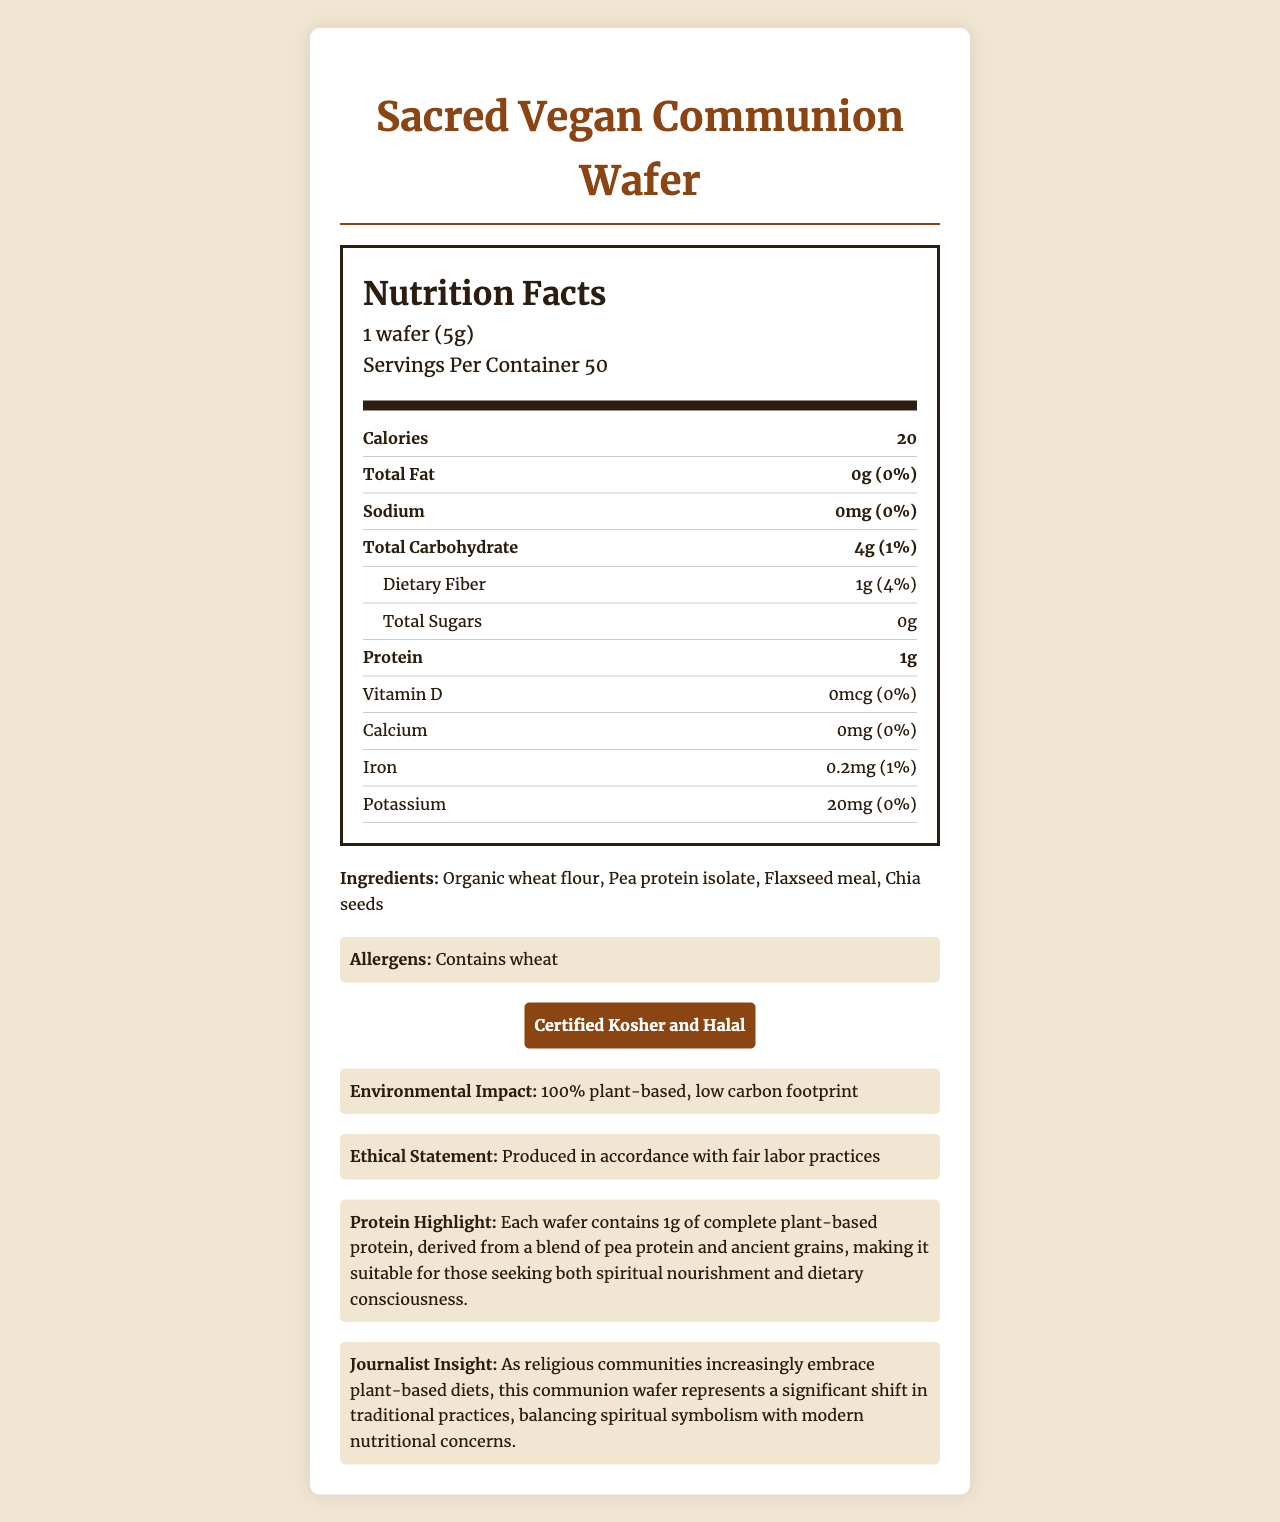what is the product name? The product name is explicitly mentioned at the top of the document.
Answer: Sacred Vegan Communion Wafer how many servings per container are there? The servings per container is listed under the serving information section.
Answer: 50 what is the serving size? The serving size is given in the serving information section.
Answer: 1 wafer (5g) how many calories does one serving contain? The number of calories per serving is listed in the nutrition facts section.
Answer: 20 what is the total carbohydrate content per serving? The total carbohydrate content per serving is listed in the nutrition facts section.
Answer: 4g what type of certification does the product have? A. Certified Organic B. Certified Humane C. Certified Kosher and Halal D. Certified Gluten-Free The certification listed in the document is "Certified Kosher and Halal".
Answer: C how much protein does one wafer contain? The protein content per serving is listed in the nutrition facts section.
Answer: 1g does the product contain any allergens? The document states, "Contains wheat" under the allergens section.
Answer: Yes what ingredients are used in the product? The ingredients are listed in the ingredients section.
Answer: Organic wheat flour, Pea protein isolate, Flaxseed meal, Chia seeds what impact does the product have on the environment? This information is provided in the document under the environmental impact section.
Answer: 100% plant-based, low carbon footprint what is the daily value percentage of dietary fiber? The daily value percentage of dietary fiber is listed in the nutrition facts section.
Answer: 4% which ingredient provides the plant-based protein content in the wafer? A. Organic wheat flour B. Chia seeds C. Pea protein isolate D. Flaxseed meal The highlighted protein information states that the protein content is derived from pea protein isolate.
Answer: C does the product contain any added sugars? Yes/No The document states that the total sugars amount to 0g, indicating no added sugars.
Answer: No briefly summarize the main idea of this document. The document is centered around providing comprehensive details on the nutritional facts, ingredients, certifications, and ethical stance of the product.
Answer: The document provides detailed nutritional information about a product called the Sacred Vegan Communion Wafer. It highlights the product's plant-based ingredients, such as pea protein isolate, and emphasizes its certification as Kosher and Halal. The document also discusses its ecological and ethical production practices. which mineral is present in a small amount (0.2mg) in the wafer? The nutrition facts section lists the iron content as 0.2mg.
Answer: Iron what is the product's ethical statement about its production? This information is provided in the ethical statement section of the document.
Answer: Produced in accordance with fair labor practices what is the daily value percentage of sodium in one serving? The daily value percentage for sodium is listed as 0%, indicating no significant amount.
Answer: 0% how many ingredients are used in the product? The ingredients section lists four items: Organic wheat flour, Pea protein isolate, Flaxseed meal, and Chia seeds.
Answer: 4 is the document user-friendly and well-structured? Why or why not? The document is user-friendly because it is well-structured with clear headings, bold sub-sections, and highlighted areas for easy readability. The use of visual distinctions like colors and fonts enhances comprehension.
Answer: Yes what is the daily value percentage of calcium? The daily value percentage for calcium is listed as 0%, indicating no significant amount of calcium.
Answer: 0% are the production practices of the product stated in the document? If so, what do they say? The document states, "Produced in accordance with fair labor practices" in the ethical statement section.
Answer: Yes does the product contain Vitamin D? The document indicates that the amount of Vitamin D is 0mcg, meaning it does not contain Vitamin D.
Answer: No what is the potassium content in one serving? The potassium content per serving is listed as 20mg in the nutrition facts section.
Answer: 20mg is the product gluten-free? The document does not provide information on whether the product is gluten-free.
Answer: Cannot be determined how is the product aligned with modern nutritional concerns? The document highlights that the product is fully plant-based, low in carbon footprint, and offers essential nutrients, aligning with environmental and dietary preferences of modern consumers.
Answer: The wafer balances spiritual symbolism with modern nutritional concerns by being 100% plant-based, low in calories, and providing complete plant-based protein. 